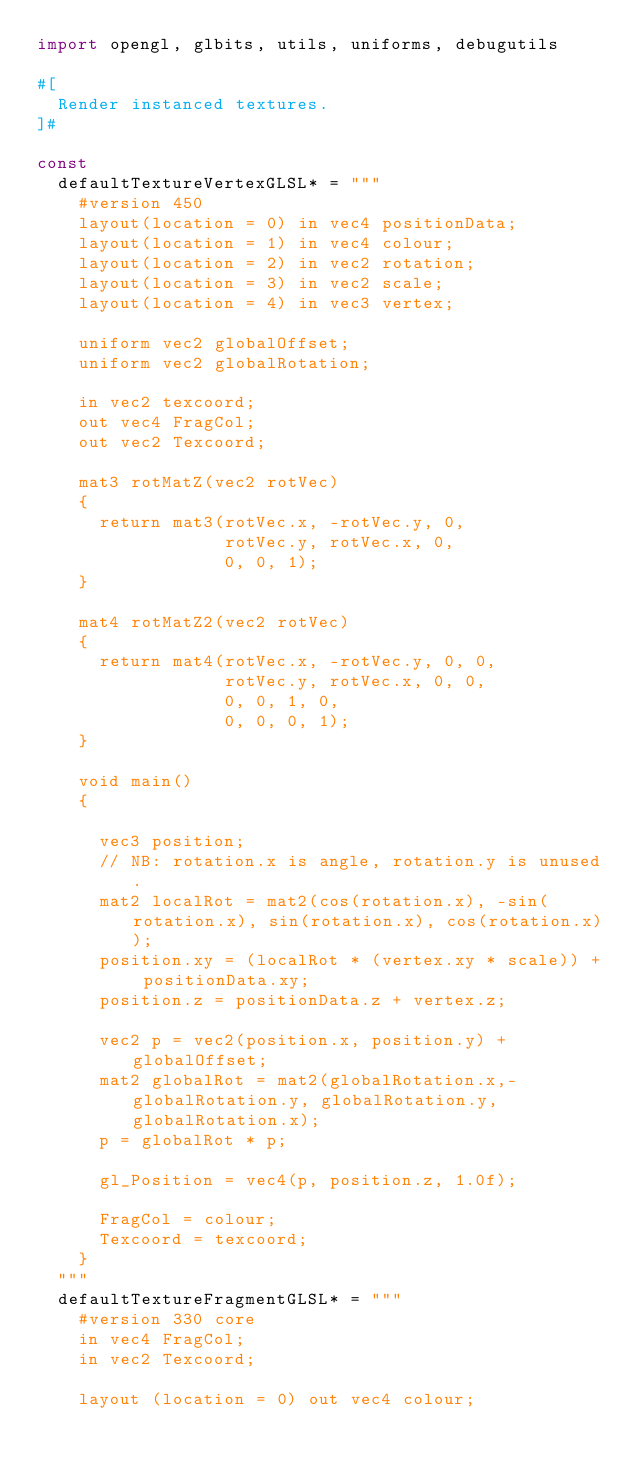<code> <loc_0><loc_0><loc_500><loc_500><_Nim_>import opengl, glbits, utils, uniforms, debugutils

#[
  Render instanced textures.
]#

const
  defaultTextureVertexGLSL* = """
    #version 450
    layout(location = 0) in vec4 positionData;
    layout(location = 1) in vec4 colour;
    layout(location = 2) in vec2 rotation;
    layout(location = 3) in vec2 scale;
    layout(location = 4) in vec3 vertex;

    uniform vec2 globalOffset;
    uniform vec2 globalRotation;

    in vec2 texcoord;
    out vec4 FragCol;
    out vec2 Texcoord;

    mat3 rotMatZ(vec2 rotVec)
    {
      return mat3(rotVec.x, -rotVec.y, 0,
                  rotVec.y, rotVec.x, 0,
                  0, 0, 1);
    }

    mat4 rotMatZ2(vec2 rotVec)
    {
      return mat4(rotVec.x, -rotVec.y, 0, 0,
                  rotVec.y, rotVec.x, 0, 0,
                  0, 0, 1, 0,
                  0, 0, 0, 1);
    }

    void main()
    {

      vec3 position;
      // NB: rotation.x is angle, rotation.y is unused.
      mat2 localRot = mat2(cos(rotation.x), -sin(rotation.x), sin(rotation.x), cos(rotation.x));
      position.xy = (localRot * (vertex.xy * scale)) + positionData.xy;
      position.z = positionData.z + vertex.z;

      vec2 p = vec2(position.x, position.y) + globalOffset;
      mat2 globalRot = mat2(globalRotation.x,-globalRotation.y, globalRotation.y, globalRotation.x);
      p = globalRot * p;
      
      gl_Position = vec4(p, position.z, 1.0f);

      FragCol = colour;
      Texcoord = texcoord;
    }
  """
  defaultTextureFragmentGLSL* = """
    #version 330 core
    in vec4 FragCol;
    in vec2 Texcoord;

    layout (location = 0) out vec4 colour;
</code> 